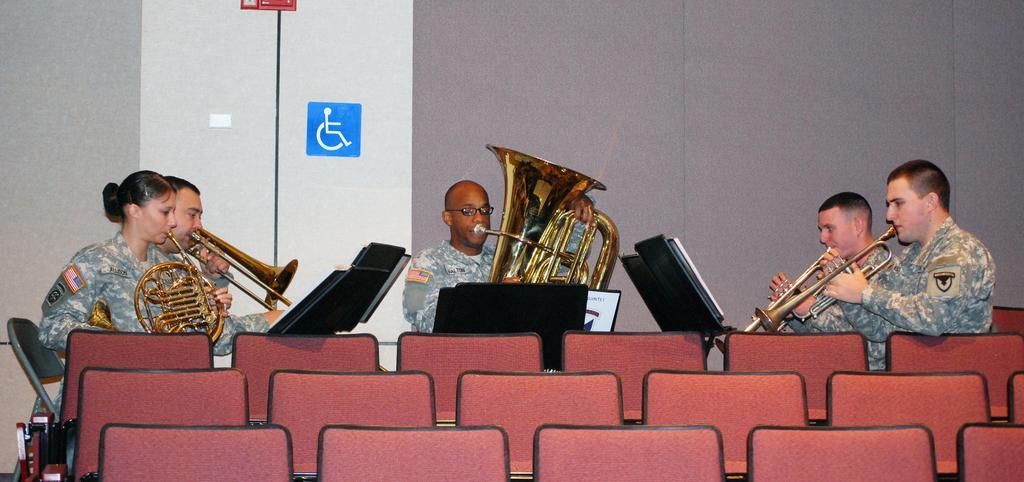Could you give a brief overview of what you see in this image? In the image we can see there are people sitting, they are wearing army clothes and they are holding musical instruments. Here we can see chairs, instruction poster and the wall. 